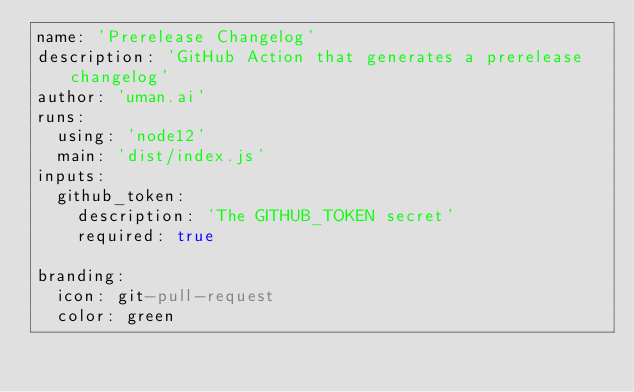Convert code to text. <code><loc_0><loc_0><loc_500><loc_500><_YAML_>name: 'Prerelease Changelog'
description: 'GitHub Action that generates a prerelease changelog'
author: 'uman.ai'
runs:
  using: 'node12'
  main: 'dist/index.js'
inputs:
  github_token:
    description: 'The GITHUB_TOKEN secret'
    required: true

branding:
  icon: git-pull-request
  color: green</code> 